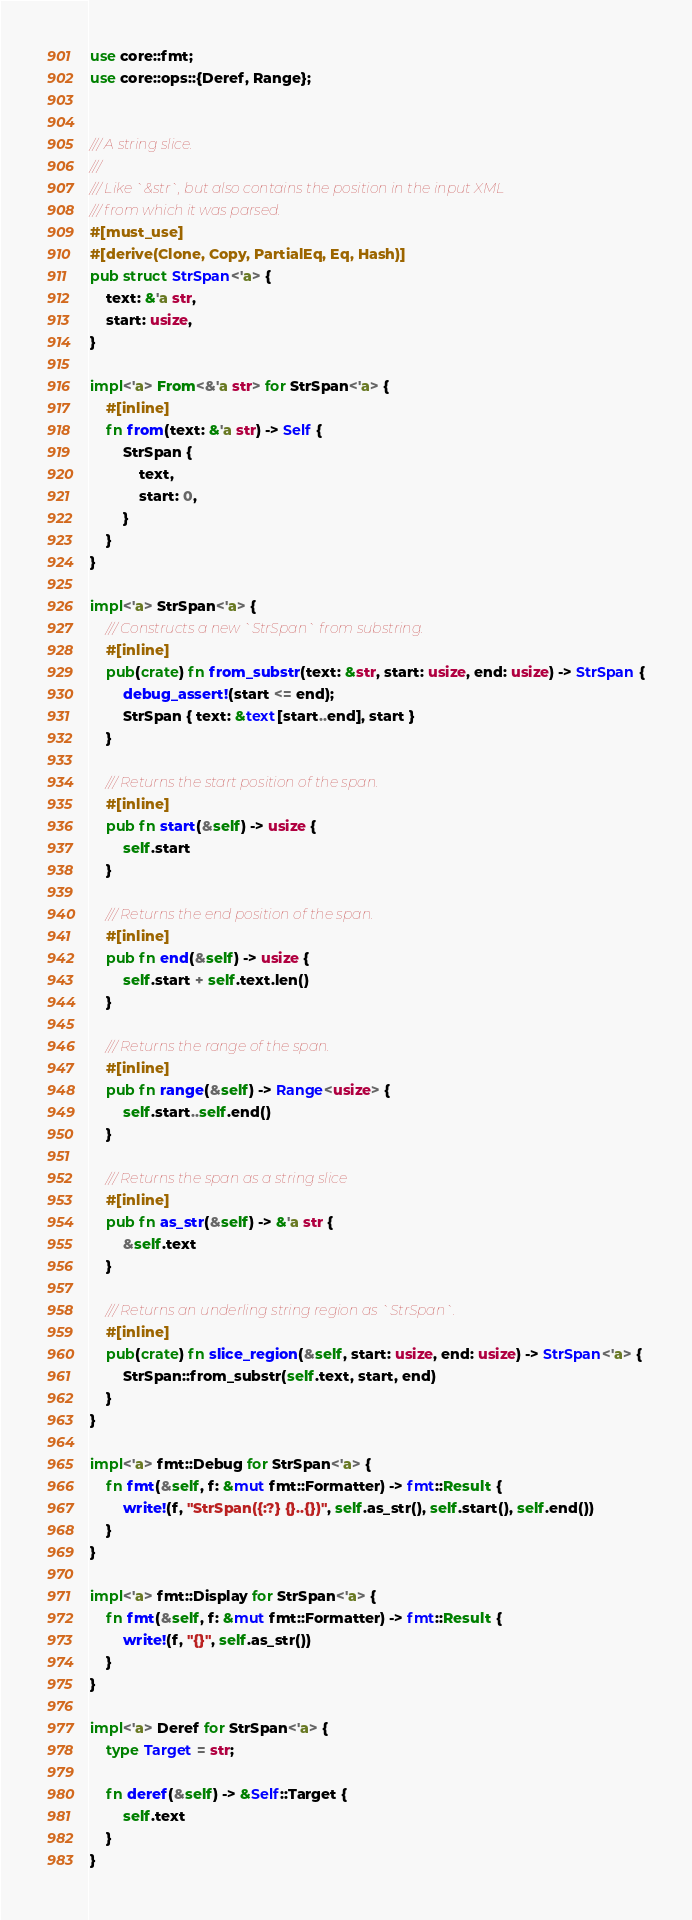<code> <loc_0><loc_0><loc_500><loc_500><_Rust_>use core::fmt;
use core::ops::{Deref, Range};


/// A string slice.
///
/// Like `&str`, but also contains the position in the input XML
/// from which it was parsed.
#[must_use]
#[derive(Clone, Copy, PartialEq, Eq, Hash)]
pub struct StrSpan<'a> {
    text: &'a str,
    start: usize,
}

impl<'a> From<&'a str> for StrSpan<'a> {
    #[inline]
    fn from(text: &'a str) -> Self {
        StrSpan {
            text,
            start: 0,
        }
    }
}

impl<'a> StrSpan<'a> {
    /// Constructs a new `StrSpan` from substring.
    #[inline]
    pub(crate) fn from_substr(text: &str, start: usize, end: usize) -> StrSpan {
        debug_assert!(start <= end);
        StrSpan { text: &text[start..end], start }
    }

    /// Returns the start position of the span.
    #[inline]
    pub fn start(&self) -> usize {
        self.start
    }

    /// Returns the end position of the span.
    #[inline]
    pub fn end(&self) -> usize {
        self.start + self.text.len()
    }

    /// Returns the range of the span.
    #[inline]
    pub fn range(&self) -> Range<usize> {
        self.start..self.end()
    }

    /// Returns the span as a string slice
    #[inline]
    pub fn as_str(&self) -> &'a str {
        &self.text
    }

    /// Returns an underling string region as `StrSpan`.
    #[inline]
    pub(crate) fn slice_region(&self, start: usize, end: usize) -> StrSpan<'a> {
        StrSpan::from_substr(self.text, start, end)
    }
}

impl<'a> fmt::Debug for StrSpan<'a> {
    fn fmt(&self, f: &mut fmt::Formatter) -> fmt::Result {
        write!(f, "StrSpan({:?} {}..{})", self.as_str(), self.start(), self.end())
    }
}

impl<'a> fmt::Display for StrSpan<'a> {
    fn fmt(&self, f: &mut fmt::Formatter) -> fmt::Result {
        write!(f, "{}", self.as_str())
    }
}

impl<'a> Deref for StrSpan<'a> {
    type Target = str;

    fn deref(&self) -> &Self::Target {
        self.text
    }
}
</code> 